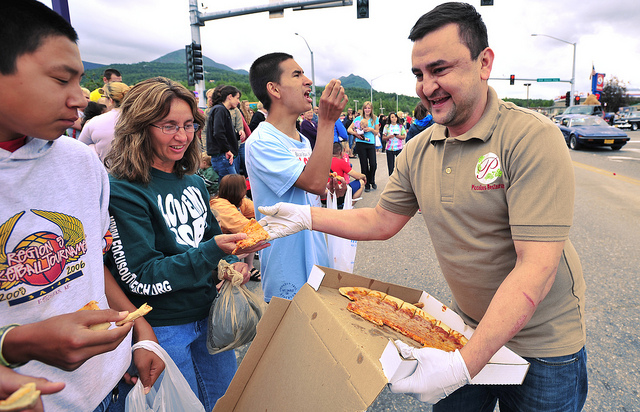Identify the text displayed in this image. Region 2006 Region 2003 LOUE P 